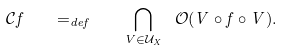Convert formula to latex. <formula><loc_0><loc_0><loc_500><loc_500>\mathcal { C } f \quad = _ { d e f } \quad \bigcap _ { V \in \mathcal { U } _ { X } } \ \mathcal { O } ( V \circ f \circ V ) .</formula> 